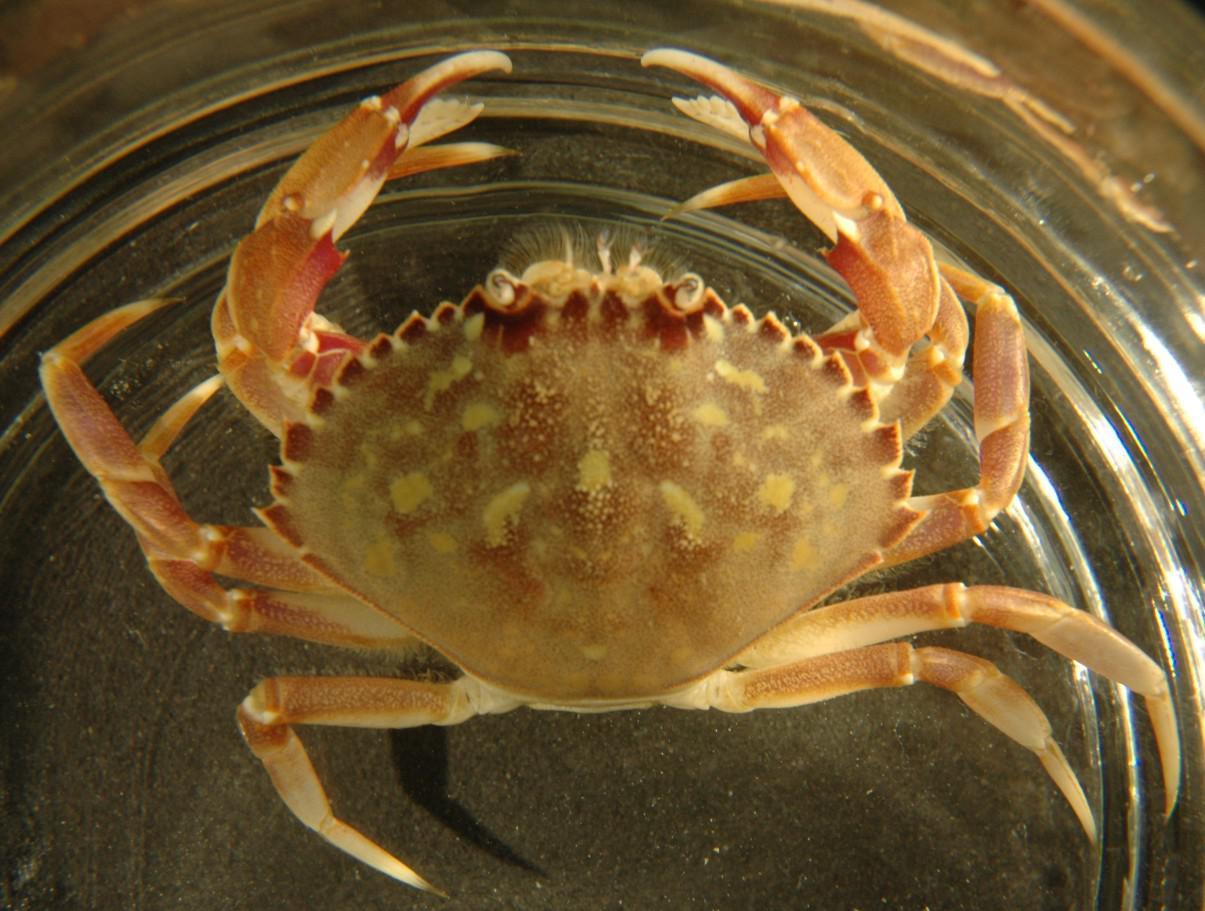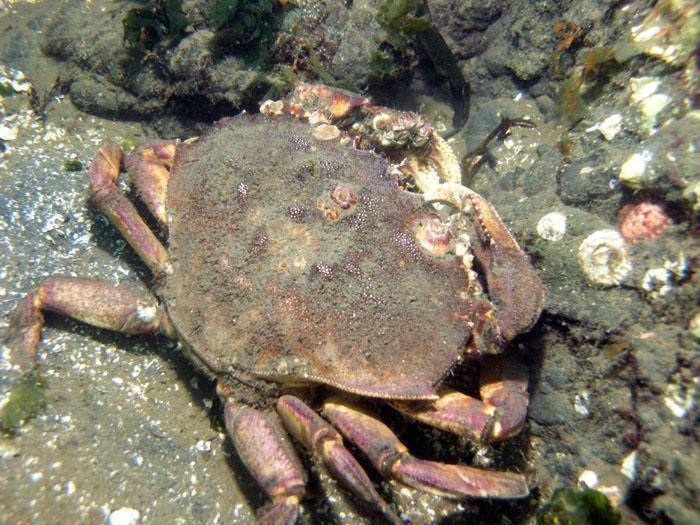The first image is the image on the left, the second image is the image on the right. Evaluate the accuracy of this statement regarding the images: "Crabs are facing in opposite directions.". Is it true? Answer yes or no. No. The first image is the image on the left, the second image is the image on the right. Analyze the images presented: Is the assertion "Each image is a from-the-top view of one crab, but one image shows a crab with its face and front claws on the top, and one shows them at the bottom." valid? Answer yes or no. No. 